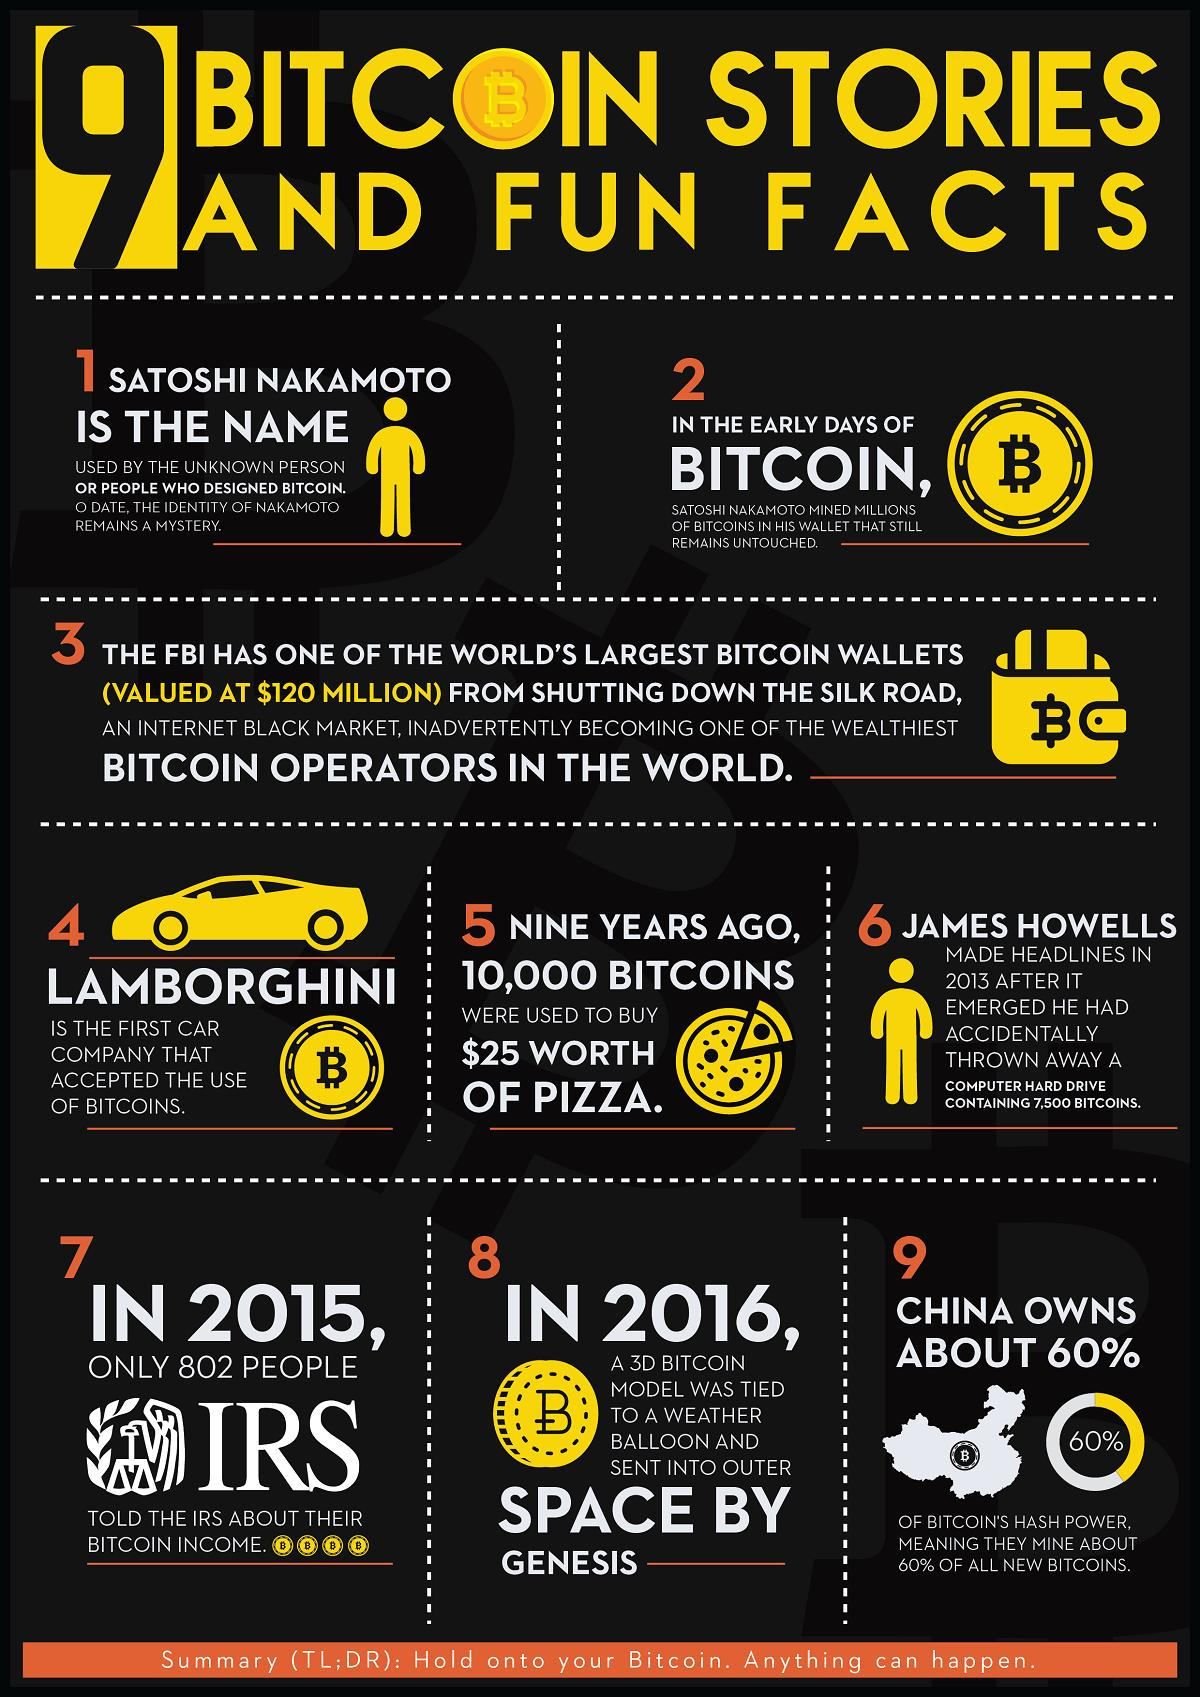Point out several critical features in this image. Bitcoin is mined by a country that holds a significant percentage of its total production. That country is China. I, [name], declare that I sent a 3D bitcoin model to outer space. The sender was Genesis. In the past, 10,000 bitcoins was equivalent to $25 worth of pizza. The Federal Bureau of Investigation (FBI) obtained a Bitcoin wallet from the Silk Road. 